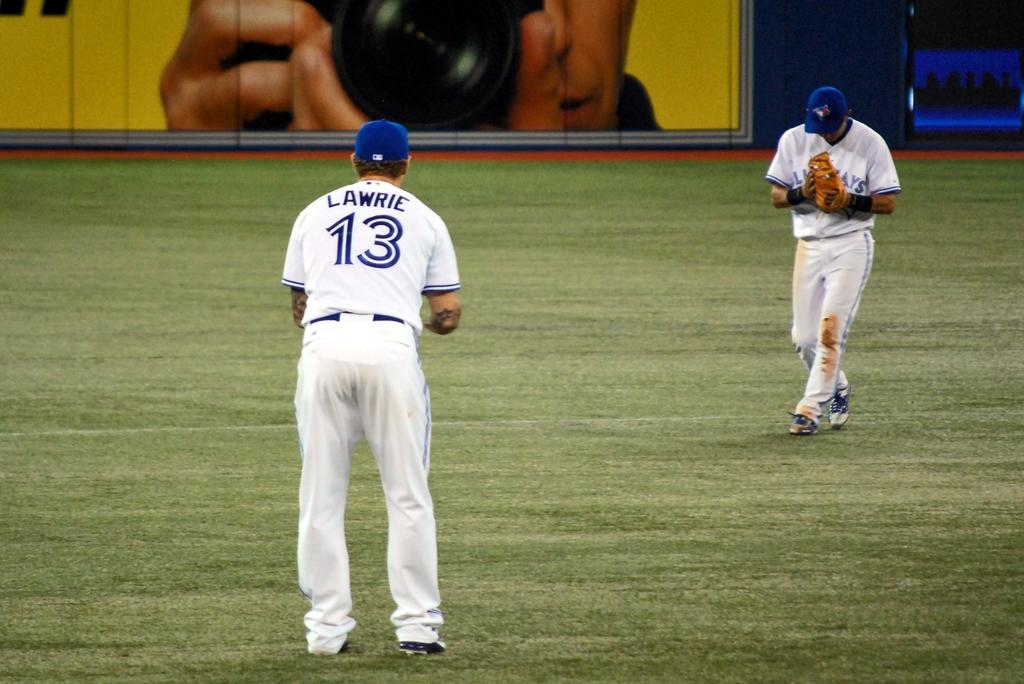How many people are in the image? There are two persons in the image. What are the persons doing in the image? The persons are standing on the ground. What color dress are the persons wearing? Both persons are wearing a white color dress. What color cap are the persons wearing? Both persons are wearing a blue color cap. What can be seen at the top of the image? There is a photo of a person holding a camera visible at the top of the image. What type of chair is the yam sitting on in the image? There is no yam or chair present in the image. 